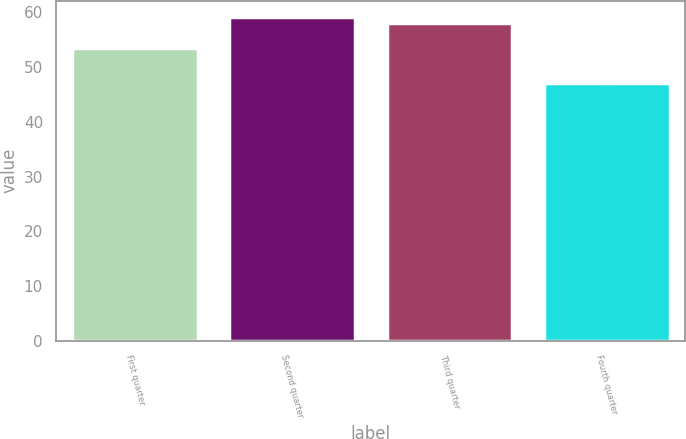Convert chart. <chart><loc_0><loc_0><loc_500><loc_500><bar_chart><fcel>First quarter<fcel>Second quarter<fcel>Third quarter<fcel>Fourth quarter<nl><fcel>53.48<fcel>59.13<fcel>58<fcel>47.16<nl></chart> 